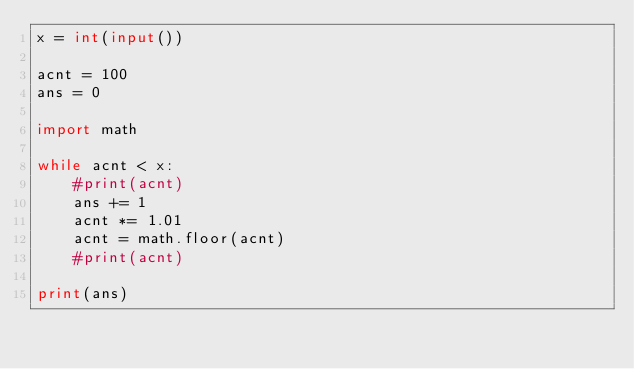<code> <loc_0><loc_0><loc_500><loc_500><_Python_>x = int(input())

acnt = 100
ans = 0

import math

while acnt < x:
    #print(acnt)
    ans += 1
    acnt *= 1.01
    acnt = math.floor(acnt)
    #print(acnt)

print(ans)</code> 